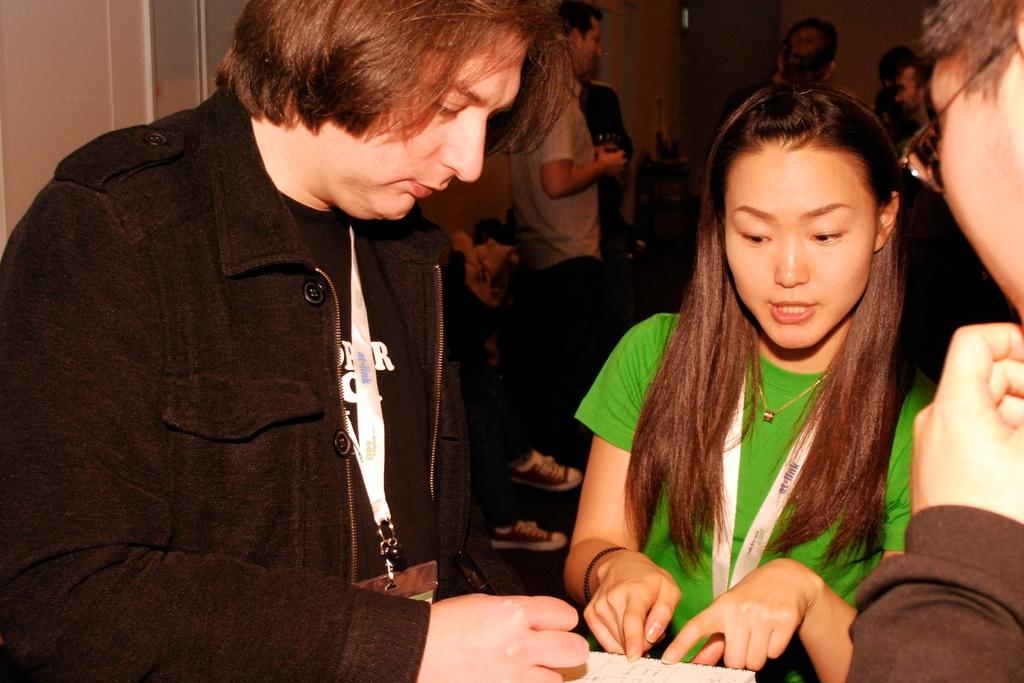How many people are in the image? There are many people in the image. Can you describe the person who stands out in the middle of the group? One person is wearing a green t-shirt and is in the middle of the group. What is the person in the green t-shirt doing? The person in the green t-shirt is looking at an object. What type of hands can be seen in the image? There is no specific mention of hands in the image, so it is not possible to answer that question. 